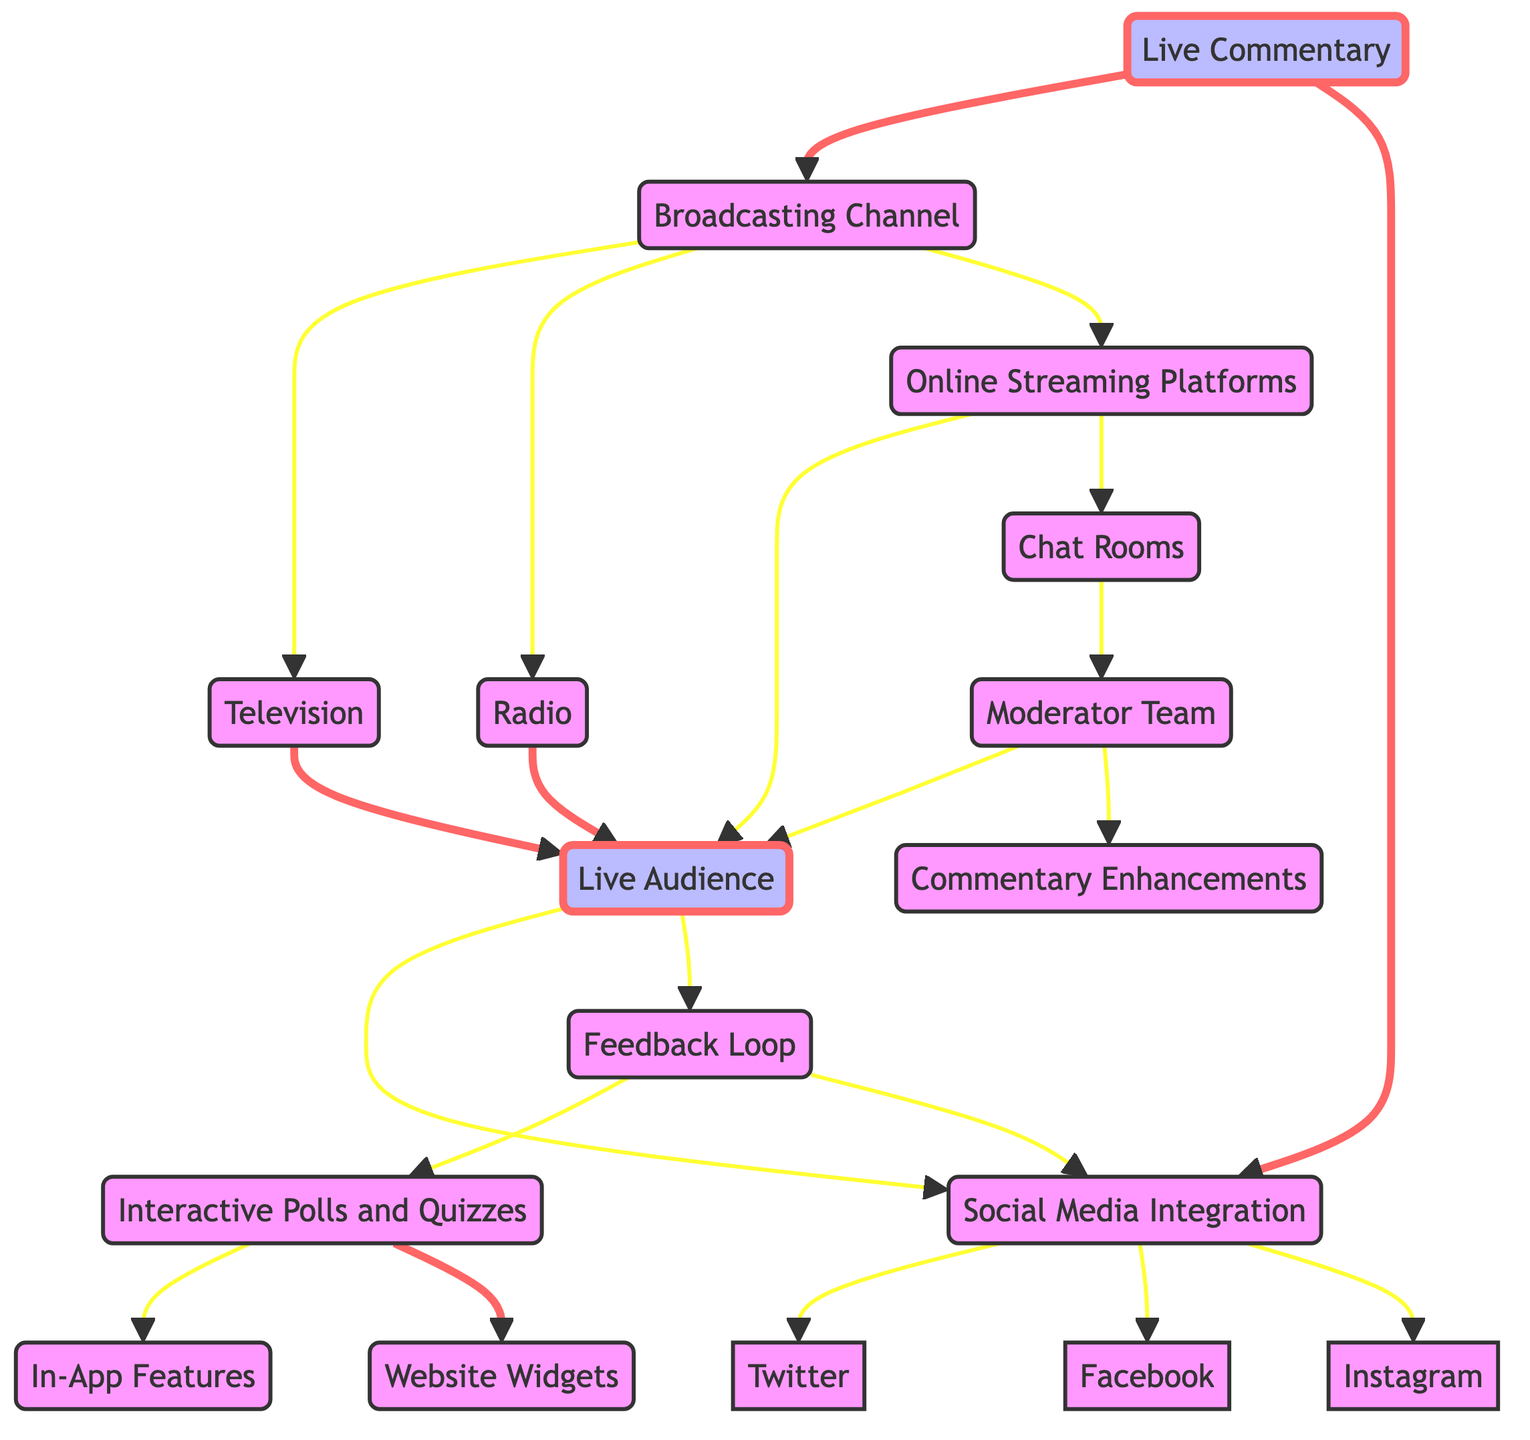What are the main engagement channels illustrated in the diagram? The diagram highlights three primary engagement channels: Live Commentary, Broadcasting Channel, and Social Media Integration.
Answer: Live Commentary, Broadcasting Channel, Social Media Integration How many connections does the Broadcasting Channel have? The Broadcasting Channel connects to three nodes: Television, Radio, and Online Streaming Platforms. Thus, it has three connections.
Answer: 3 What type of medium is represented by the Television block? The Television block is categorized as a traditional broadcasting medium, which indicates its function in live sports broadcasts.
Answer: Traditional broadcasting medium Who constitutes the Live Audience in the diagram? The Live Audience includes viewers and listeners experiencing the broadcast in real-time and is involved in engagements through Social Media and the Feedback Loop.
Answer: Viewers and listeners Which node integrates with Chat Rooms? Online Streaming Platforms connect to Chat Rooms, indicating that viewers can discuss the broadcast while streaming.
Answer: Online Streaming Platforms How does audience feedback influence the broadcast, according to the diagram? The Feedback Loop receives input from the Live Audience and is connected to both Interactive Polls and Quizzes and Social Media Integration, allowing for the integration of audience feedback.
Answer: Feedback Loop Describe how the Moderator Team is connected to other elements in the diagram. The Moderator Team connects directly with Live Audience and facilitates Commentary Enhancements, indicating its role in managing audience interaction and improving commentary.
Answer: Live Audience and Commentary Enhancements Which social media platforms are listed in the Social Media Integration block? The Social Media Integration block includes three platforms: Twitter, Facebook, and Instagram, which are specifically mentioned as connection points.
Answer: Twitter, Facebook, Instagram What is the purpose of Interactive Polls and Quizzes? The purpose of Interactive Polls and Quizzes is to engage the audience through real-time polling and trivia questions, allowing for interaction during the broadcast.
Answer: Audience engagement through polling and trivia How does the loop of audience engagement return feedback to the broadcasters? The Feedback Loop connects back to Interactive Polls and Quizzes and Social Media Integration, showing that audience input can alter the ongoing broadcast or commentary based on their interactions.
Answer: Feedback Loop 